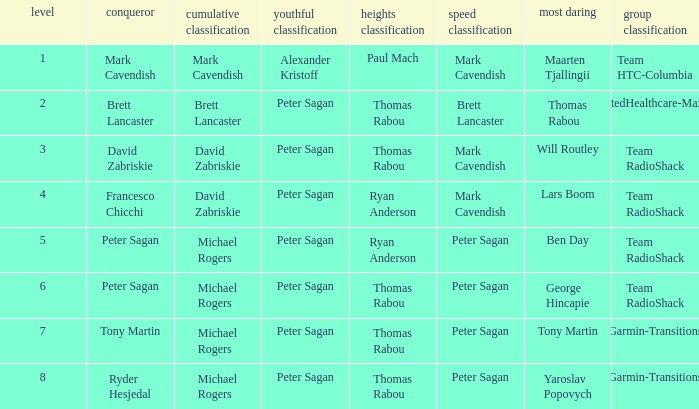During the time yaroslav popovych was awarded the most courageous title, who was the winner of the mountains classification? Thomas Rabou. 